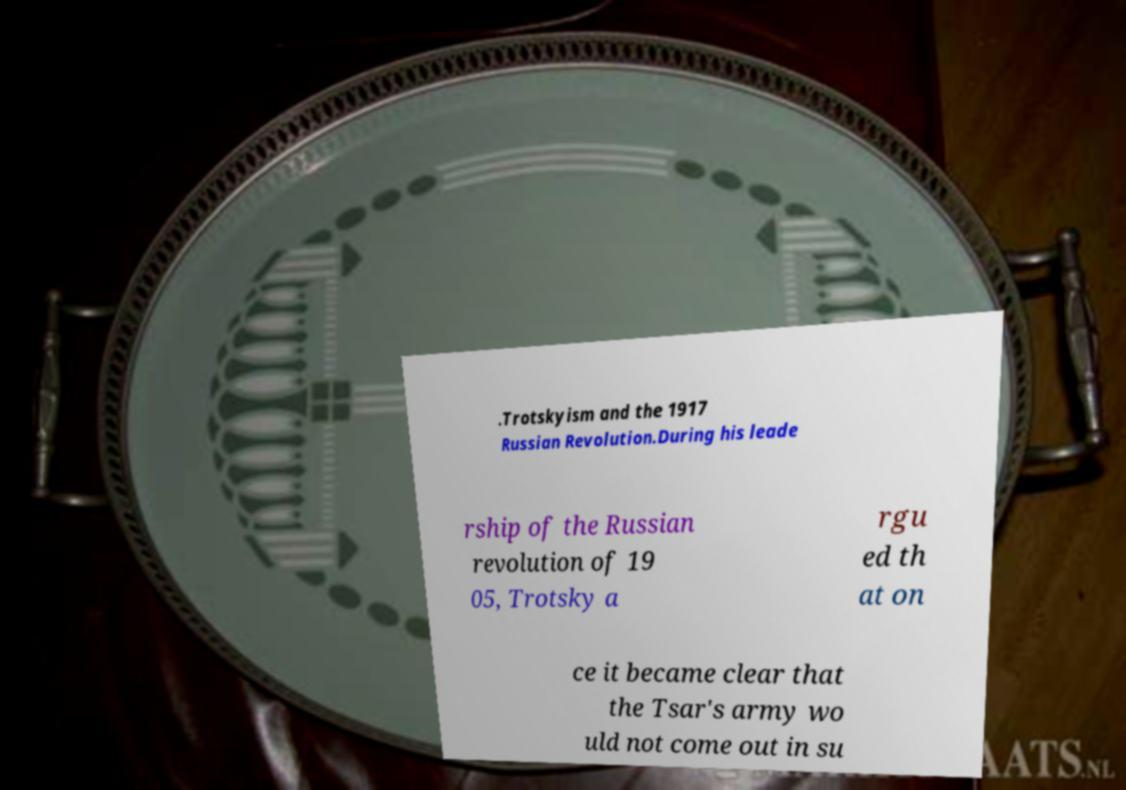There's text embedded in this image that I need extracted. Can you transcribe it verbatim? .Trotskyism and the 1917 Russian Revolution.During his leade rship of the Russian revolution of 19 05, Trotsky a rgu ed th at on ce it became clear that the Tsar's army wo uld not come out in su 